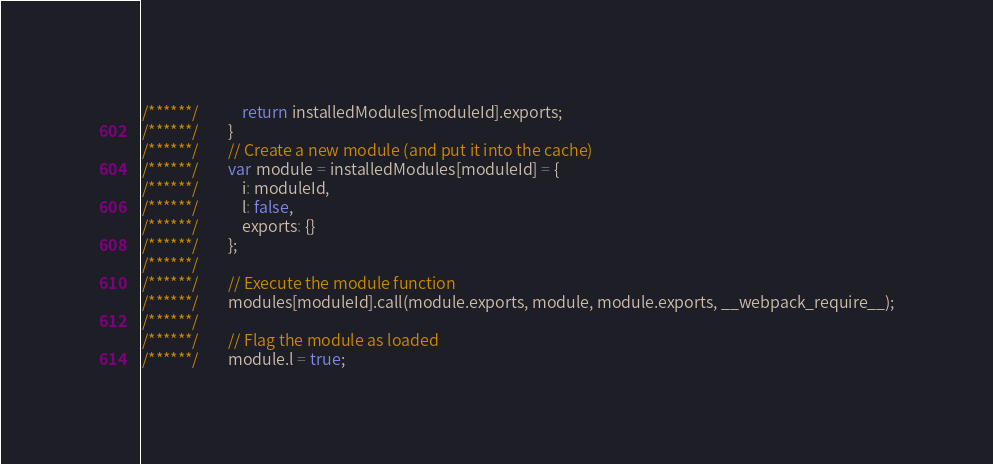<code> <loc_0><loc_0><loc_500><loc_500><_JavaScript_>/******/ 			return installedModules[moduleId].exports;
/******/ 		}
/******/ 		// Create a new module (and put it into the cache)
/******/ 		var module = installedModules[moduleId] = {
/******/ 			i: moduleId,
/******/ 			l: false,
/******/ 			exports: {}
/******/ 		};
/******/
/******/ 		// Execute the module function
/******/ 		modules[moduleId].call(module.exports, module, module.exports, __webpack_require__);
/******/
/******/ 		// Flag the module as loaded
/******/ 		module.l = true;</code> 